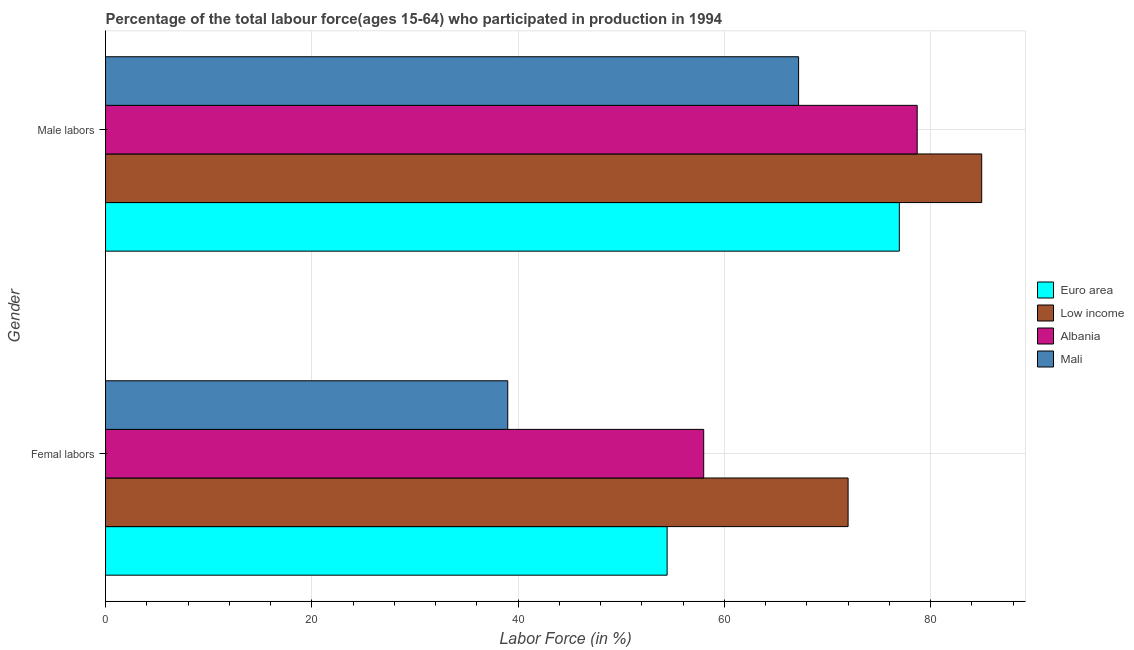Are the number of bars per tick equal to the number of legend labels?
Keep it short and to the point. Yes. How many bars are there on the 2nd tick from the bottom?
Offer a terse response. 4. What is the label of the 1st group of bars from the top?
Offer a very short reply. Male labors. What is the percentage of male labour force in Low income?
Provide a succinct answer. 84.95. Across all countries, what is the maximum percentage of female labor force?
Provide a short and direct response. 72. Across all countries, what is the minimum percentage of male labour force?
Give a very brief answer. 67.2. In which country was the percentage of female labor force minimum?
Make the answer very short. Mali. What is the total percentage of female labor force in the graph?
Make the answer very short. 223.45. What is the difference between the percentage of female labor force in Low income and that in Mali?
Make the answer very short. 33. What is the difference between the percentage of female labor force in Mali and the percentage of male labour force in Low income?
Provide a succinct answer. -45.95. What is the average percentage of female labor force per country?
Your answer should be very brief. 55.86. What is the difference between the percentage of male labour force and percentage of female labor force in Mali?
Make the answer very short. 28.2. What is the ratio of the percentage of female labor force in Mali to that in Low income?
Provide a short and direct response. 0.54. Is the percentage of female labor force in Albania less than that in Euro area?
Provide a succinct answer. No. In how many countries, is the percentage of male labour force greater than the average percentage of male labour force taken over all countries?
Give a very brief answer. 3. What does the 3rd bar from the top in Male labors represents?
Your answer should be compact. Low income. What does the 4th bar from the bottom in Femal labors represents?
Keep it short and to the point. Mali. How many bars are there?
Offer a terse response. 8. How many countries are there in the graph?
Give a very brief answer. 4. What is the difference between two consecutive major ticks on the X-axis?
Offer a terse response. 20. Are the values on the major ticks of X-axis written in scientific E-notation?
Your answer should be very brief. No. Does the graph contain any zero values?
Offer a terse response. No. Does the graph contain grids?
Your answer should be very brief. Yes. How many legend labels are there?
Ensure brevity in your answer.  4. What is the title of the graph?
Provide a succinct answer. Percentage of the total labour force(ages 15-64) who participated in production in 1994. Does "St. Lucia" appear as one of the legend labels in the graph?
Your answer should be very brief. No. What is the label or title of the X-axis?
Your answer should be very brief. Labor Force (in %). What is the Labor Force (in %) in Euro area in Femal labors?
Offer a very short reply. 54.45. What is the Labor Force (in %) in Low income in Femal labors?
Your answer should be very brief. 72. What is the Labor Force (in %) in Euro area in Male labors?
Your response must be concise. 76.97. What is the Labor Force (in %) in Low income in Male labors?
Your answer should be compact. 84.95. What is the Labor Force (in %) in Albania in Male labors?
Give a very brief answer. 78.7. What is the Labor Force (in %) in Mali in Male labors?
Give a very brief answer. 67.2. Across all Gender, what is the maximum Labor Force (in %) of Euro area?
Your answer should be compact. 76.97. Across all Gender, what is the maximum Labor Force (in %) in Low income?
Offer a very short reply. 84.95. Across all Gender, what is the maximum Labor Force (in %) of Albania?
Your answer should be compact. 78.7. Across all Gender, what is the maximum Labor Force (in %) in Mali?
Keep it short and to the point. 67.2. Across all Gender, what is the minimum Labor Force (in %) in Euro area?
Your response must be concise. 54.45. Across all Gender, what is the minimum Labor Force (in %) of Low income?
Give a very brief answer. 72. Across all Gender, what is the minimum Labor Force (in %) in Albania?
Offer a very short reply. 58. What is the total Labor Force (in %) of Euro area in the graph?
Make the answer very short. 131.42. What is the total Labor Force (in %) in Low income in the graph?
Offer a very short reply. 156.95. What is the total Labor Force (in %) in Albania in the graph?
Your response must be concise. 136.7. What is the total Labor Force (in %) of Mali in the graph?
Ensure brevity in your answer.  106.2. What is the difference between the Labor Force (in %) of Euro area in Femal labors and that in Male labors?
Provide a short and direct response. -22.52. What is the difference between the Labor Force (in %) in Low income in Femal labors and that in Male labors?
Give a very brief answer. -12.95. What is the difference between the Labor Force (in %) of Albania in Femal labors and that in Male labors?
Give a very brief answer. -20.7. What is the difference between the Labor Force (in %) of Mali in Femal labors and that in Male labors?
Ensure brevity in your answer.  -28.2. What is the difference between the Labor Force (in %) in Euro area in Femal labors and the Labor Force (in %) in Low income in Male labors?
Offer a terse response. -30.5. What is the difference between the Labor Force (in %) in Euro area in Femal labors and the Labor Force (in %) in Albania in Male labors?
Offer a very short reply. -24.25. What is the difference between the Labor Force (in %) in Euro area in Femal labors and the Labor Force (in %) in Mali in Male labors?
Your answer should be very brief. -12.75. What is the difference between the Labor Force (in %) in Low income in Femal labors and the Labor Force (in %) in Albania in Male labors?
Your response must be concise. -6.7. What is the difference between the Labor Force (in %) of Low income in Femal labors and the Labor Force (in %) of Mali in Male labors?
Keep it short and to the point. 4.8. What is the difference between the Labor Force (in %) of Albania in Femal labors and the Labor Force (in %) of Mali in Male labors?
Offer a terse response. -9.2. What is the average Labor Force (in %) of Euro area per Gender?
Give a very brief answer. 65.71. What is the average Labor Force (in %) in Low income per Gender?
Provide a short and direct response. 78.48. What is the average Labor Force (in %) in Albania per Gender?
Make the answer very short. 68.35. What is the average Labor Force (in %) of Mali per Gender?
Your answer should be compact. 53.1. What is the difference between the Labor Force (in %) of Euro area and Labor Force (in %) of Low income in Femal labors?
Provide a succinct answer. -17.55. What is the difference between the Labor Force (in %) in Euro area and Labor Force (in %) in Albania in Femal labors?
Ensure brevity in your answer.  -3.55. What is the difference between the Labor Force (in %) of Euro area and Labor Force (in %) of Mali in Femal labors?
Make the answer very short. 15.45. What is the difference between the Labor Force (in %) of Low income and Labor Force (in %) of Albania in Femal labors?
Your answer should be compact. 14. What is the difference between the Labor Force (in %) of Low income and Labor Force (in %) of Mali in Femal labors?
Ensure brevity in your answer.  33. What is the difference between the Labor Force (in %) of Euro area and Labor Force (in %) of Low income in Male labors?
Provide a short and direct response. -7.99. What is the difference between the Labor Force (in %) in Euro area and Labor Force (in %) in Albania in Male labors?
Your response must be concise. -1.73. What is the difference between the Labor Force (in %) in Euro area and Labor Force (in %) in Mali in Male labors?
Your response must be concise. 9.77. What is the difference between the Labor Force (in %) in Low income and Labor Force (in %) in Albania in Male labors?
Your answer should be compact. 6.25. What is the difference between the Labor Force (in %) in Low income and Labor Force (in %) in Mali in Male labors?
Your answer should be very brief. 17.75. What is the ratio of the Labor Force (in %) of Euro area in Femal labors to that in Male labors?
Give a very brief answer. 0.71. What is the ratio of the Labor Force (in %) of Low income in Femal labors to that in Male labors?
Offer a very short reply. 0.85. What is the ratio of the Labor Force (in %) of Albania in Femal labors to that in Male labors?
Provide a short and direct response. 0.74. What is the ratio of the Labor Force (in %) in Mali in Femal labors to that in Male labors?
Ensure brevity in your answer.  0.58. What is the difference between the highest and the second highest Labor Force (in %) in Euro area?
Ensure brevity in your answer.  22.52. What is the difference between the highest and the second highest Labor Force (in %) in Low income?
Your response must be concise. 12.95. What is the difference between the highest and the second highest Labor Force (in %) of Albania?
Ensure brevity in your answer.  20.7. What is the difference between the highest and the second highest Labor Force (in %) in Mali?
Keep it short and to the point. 28.2. What is the difference between the highest and the lowest Labor Force (in %) of Euro area?
Make the answer very short. 22.52. What is the difference between the highest and the lowest Labor Force (in %) of Low income?
Your answer should be very brief. 12.95. What is the difference between the highest and the lowest Labor Force (in %) of Albania?
Make the answer very short. 20.7. What is the difference between the highest and the lowest Labor Force (in %) in Mali?
Provide a succinct answer. 28.2. 